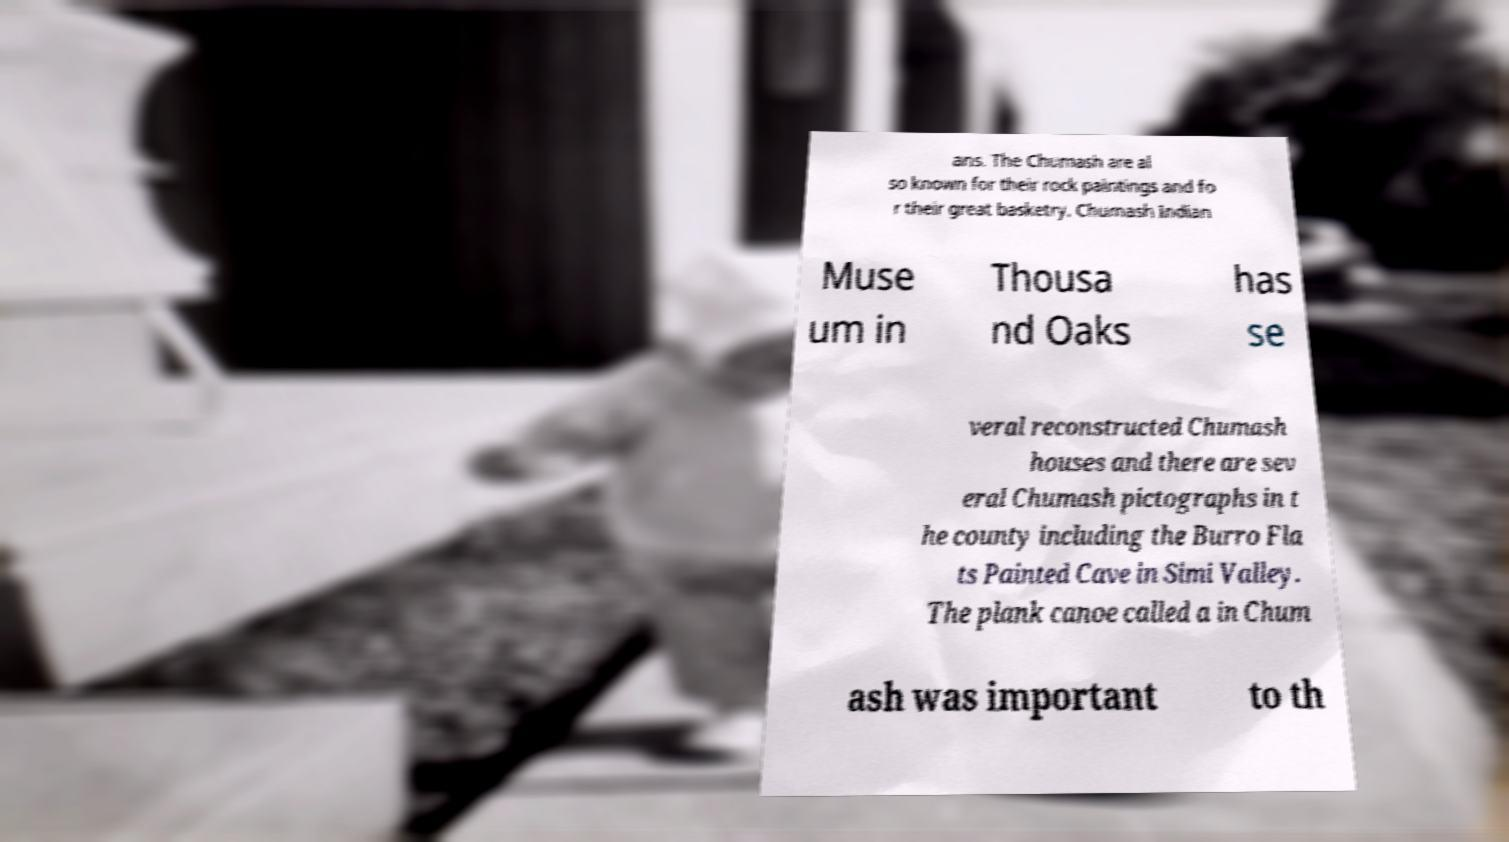What messages or text are displayed in this image? I need them in a readable, typed format. ans. The Chumash are al so known for their rock paintings and fo r their great basketry. Chumash Indian Muse um in Thousa nd Oaks has se veral reconstructed Chumash houses and there are sev eral Chumash pictographs in t he county including the Burro Fla ts Painted Cave in Simi Valley. The plank canoe called a in Chum ash was important to th 